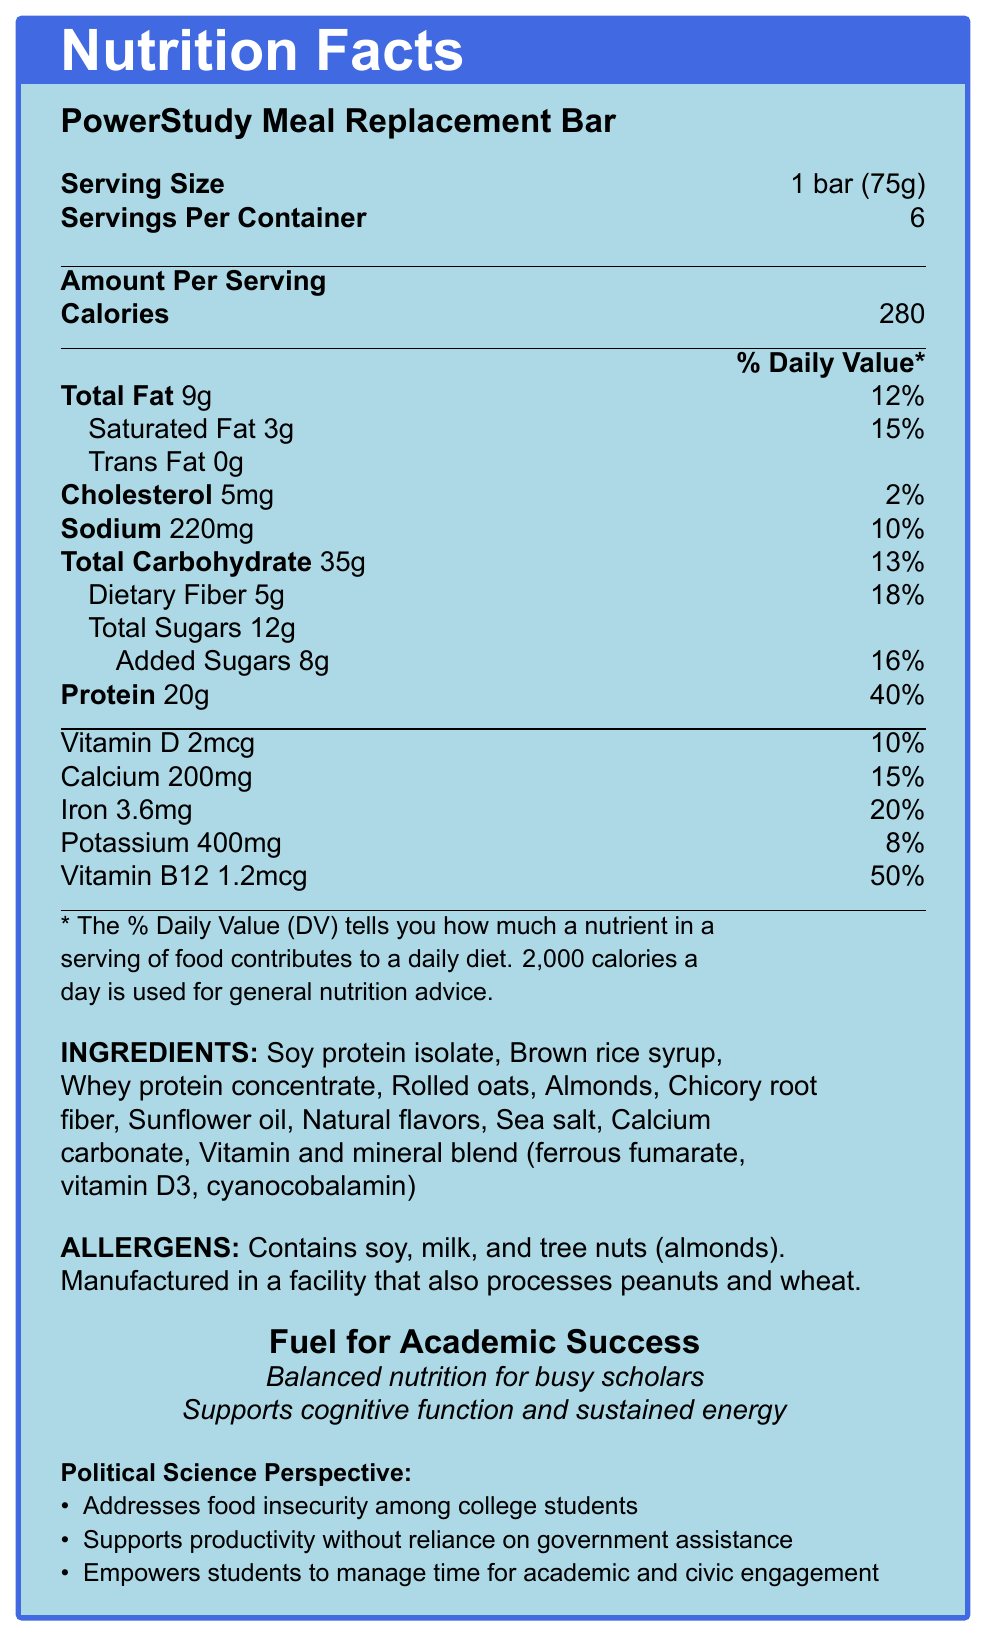What is the serving size for the PowerStudy Meal Replacement Bar? The document specifies that the serving size is one bar, which weighs 75 grams.
Answer: 1 bar (75g) How many servings are there per container? The document lists that there are 6 servings per container.
Answer: 6 How much protein is there per serving? The document shows that each serving contains 20 grams of protein.
Answer: 20g What percentage of the Daily Value for dietary fiber does one serving provide? According to the document, one serving provides 18% of the Daily Value for dietary fiber.
Answer: 18% What are the total carbohydrates per serving? The document states that there are 35 grams of total carbohydrates per serving.
Answer: 35g Which two vitamins have the highest percent Daily Value per serving? A. Vitamin D and Calcium B. Iron and Vitamin D C. Iron and Vitamin B12 D. Potassium and Vitamin B12 The document shows that Iron has a Daily Value of 20% and Vitamin B12 has a Daily Value of 50%.
Answer: C What is the amount of sodium per serving? A. 220mg B. 250mg C. 300mg D. 150mg According to the document, each serving contains 220mg of sodium.
Answer: A Does the PowerStudy Meal Replacement Bar contain any trans fat? The document specifies that there is 0g of trans fat per serving.
Answer: No Summarize the main idea of the Nutrition Facts Label for the PowerStudy Meal Replacement Bar. The document provides detailed nutrition facts, ingredients, allergens, marketing claims, and political science relevance, focusing on the nutritional benefits and social impact of the product.
Answer: The PowerStudy Meal Replacement Bar is designed for busy students, providing balanced nutrition to support academic success. Each serving (1 bar, 75g) contains 280 calories, 20g of protein, and significant percentages of Daily Values for vitamins and minerals. It is marketed as addressing food insecurity among college students, supporting productivity without government assistance, and empowering time management for academic and civic engagement. What is the main source of protein in the PowerStudy Meal Replacement Bar? The document lists soy protein isolate as the first ingredient, indicating it is the main source of protein.
Answer: Soy protein isolate Can this bar be considered a low-sodium option? The document shows that the bar contains 220mg of sodium, which is 10% of the Daily Value, indicating it is not a low-sodium option.
Answer: No What allergens are present in the PowerStudy Meal Replacement Bar? The document clearly mentions soy, milk, and tree nuts (almonds) as allergens.
Answer: Soy, milk, and tree nuts (almonds) What daily percentage of Vitamin B12 does each serving provide? The document lists Vitamin B12 at 50% of the Daily Value per serving.
Answer: 50% Is the PowerStudy Meal Replacement Bar sugar-free? The document indicates that there are 12g of total sugars and 8g of added sugars per serving.
Answer: No List three health claims made in the Nutrition Facts Label for the PowerStudy Meal Replacement Bar. The document lists these three health claims to promote the product's benefits.
Answer: Fuel for academic success, balanced nutrition for busy scholars, supports cognitive function and sustained energy What ingredient is used to provide fiber in the PowerStudy Meal Replacement Bar? The document includes chicory root fiber as one of the ingredients.
Answer: Chicory root fiber Is the PowerStudy Meal Replacement Bar suitable for someone with a peanut allergy? The document mentions it is manufactured in a facility that processes peanuts, so it may not be safe for someone with a peanut allergy.
Answer: Cannot be determined What is the bar's marketing slogan related to nutrient support for busy students? The document includes this phrase as part of its marketing slogans.
Answer: Balanced nutrition for busy scholars 